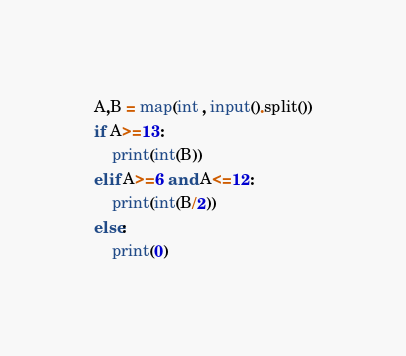Convert code to text. <code><loc_0><loc_0><loc_500><loc_500><_Python_>A,B = map(int , input().split())
if A>=13:
	print(int(B))
elif A>=6 and A<=12:
	print(int(B/2))
else:
	print(0)</code> 